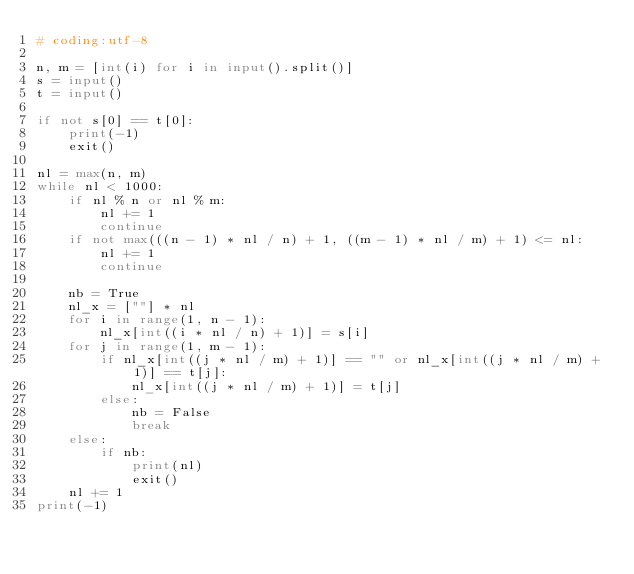<code> <loc_0><loc_0><loc_500><loc_500><_Python_># coding:utf-8

n, m = [int(i) for i in input().split()]
s = input()
t = input()

if not s[0] == t[0]:
	print(-1)
	exit()

nl = max(n, m)
while nl < 1000:
	if nl % n or nl % m:
		nl += 1
		continue
	if not max(((n - 1) * nl / n) + 1, ((m - 1) * nl / m) + 1) <= nl:
		nl += 1
		continue

	nb = True
	nl_x = [""] * nl
	for i in range(1, n - 1):
		nl_x[int((i * nl / n) + 1)] = s[i]
	for j in range(1, m - 1):
		if nl_x[int((j * nl / m) + 1)] == "" or nl_x[int((j * nl / m) + 1)] == t[j]:
			nl_x[int((j * nl / m) + 1)] = t[j]
		else:
			nb = False
			break
	else:
		if nb:
			print(nl)
			exit()
	nl += 1
print(-1)
</code> 